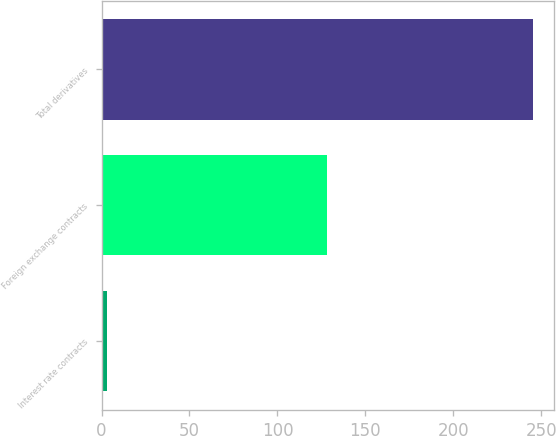<chart> <loc_0><loc_0><loc_500><loc_500><bar_chart><fcel>Interest rate contracts<fcel>Foreign exchange contracts<fcel>Total derivatives<nl><fcel>3<fcel>128<fcel>245<nl></chart> 